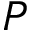<formula> <loc_0><loc_0><loc_500><loc_500>P</formula> 